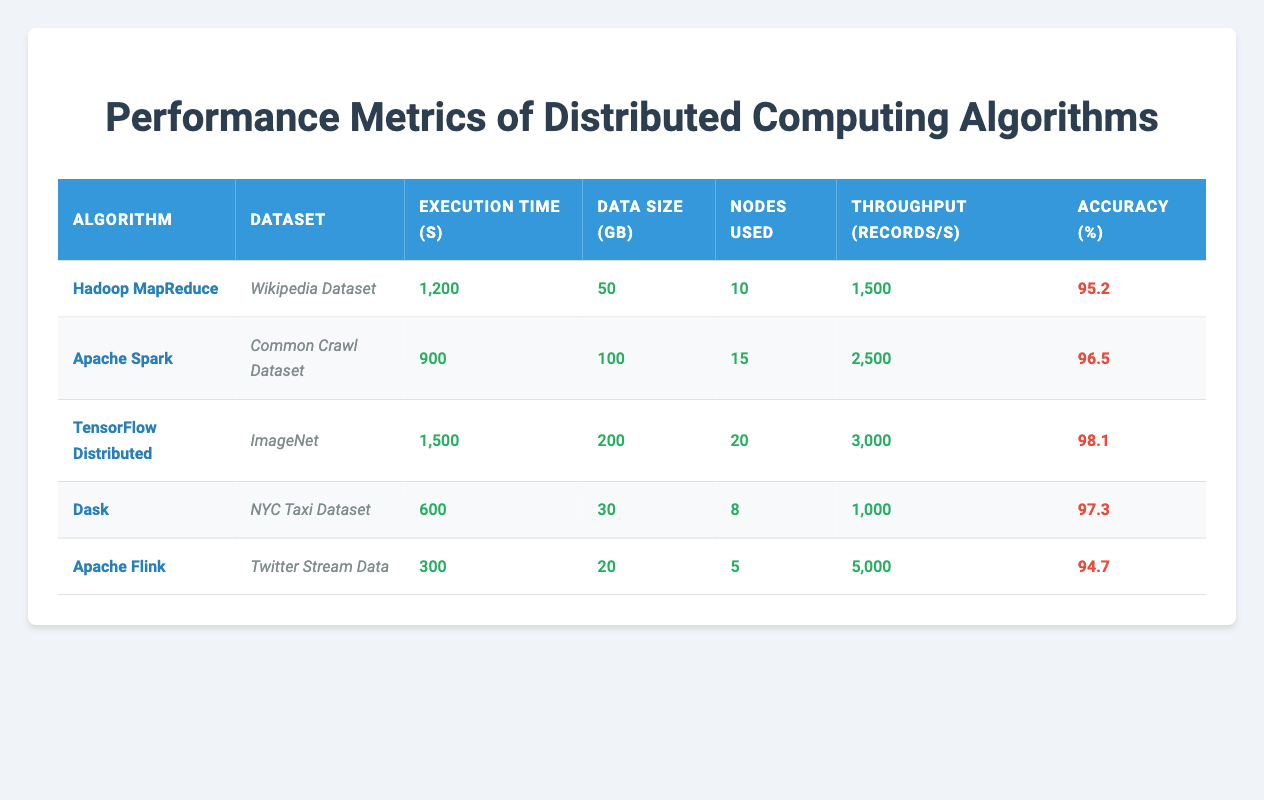What is the execution time of Apache Spark on the Common Crawl Dataset? The table lists the execution time for Apache Spark under the column "Execution Time (s)" next to the "Common Crawl Dataset". The value is 900 seconds.
Answer: 900 seconds Which algorithm had the highest throughput? By looking at the "Throughput (records/s)" column, we see that Apache Flink has the highest value at 5000 records per second.
Answer: Apache Flink What is the average accuracy of the algorithms listed? To calculate the average accuracy, we sum all the accuracy percentages (95.2 + 96.5 + 98.1 + 97.3 + 94.7 = 482.8) and divide by the number of algorithms (5). Thus, the average accuracy is 482.8 / 5 = 96.56.
Answer: 96.56 Did Dask use more nodes than Hadoop MapReduce? Checking the "Nodes Used" column, Dask used 8 nodes while Hadoop MapReduce used 10 nodes. Since 8 is less than 10, the statement is false.
Answer: No Which algorithm had the longest execution time? The longest execution time can be found by comparing the execution times in the "Execution Time (s)" column. TensorFlow Distributed has 1500 seconds, which is the highest among all listed algorithms.
Answer: TensorFlow Distributed 